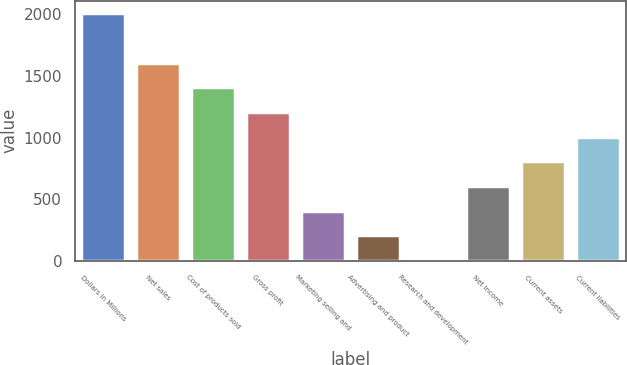Convert chart to OTSL. <chart><loc_0><loc_0><loc_500><loc_500><bar_chart><fcel>Dollars in Millions<fcel>Net sales<fcel>Cost of products sold<fcel>Gross profit<fcel>Marketing selling and<fcel>Advertising and product<fcel>Research and development<fcel>Net income<fcel>Current assets<fcel>Current liabilities<nl><fcel>2011<fcel>1609.8<fcel>1409.2<fcel>1208.6<fcel>406.2<fcel>205.6<fcel>5<fcel>606.8<fcel>807.4<fcel>1008<nl></chart> 